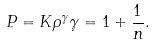<formula> <loc_0><loc_0><loc_500><loc_500>P = K \rho ^ { \gamma } \gamma = 1 + \frac { 1 } { n } .</formula> 